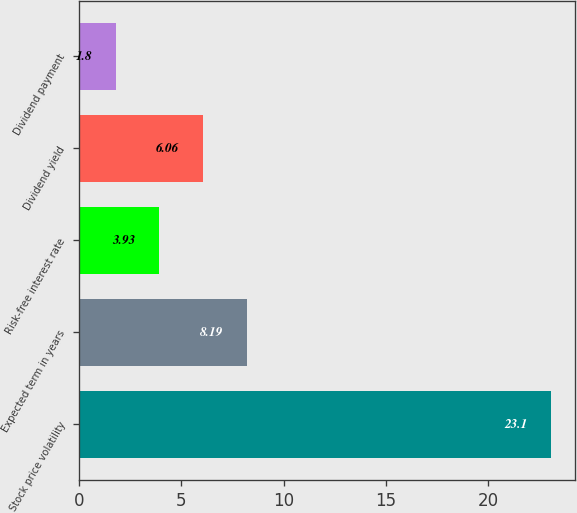<chart> <loc_0><loc_0><loc_500><loc_500><bar_chart><fcel>Stock price volatility<fcel>Expected term in years<fcel>Risk-free interest rate<fcel>Dividend yield<fcel>Dividend payment<nl><fcel>23.1<fcel>8.19<fcel>3.93<fcel>6.06<fcel>1.8<nl></chart> 